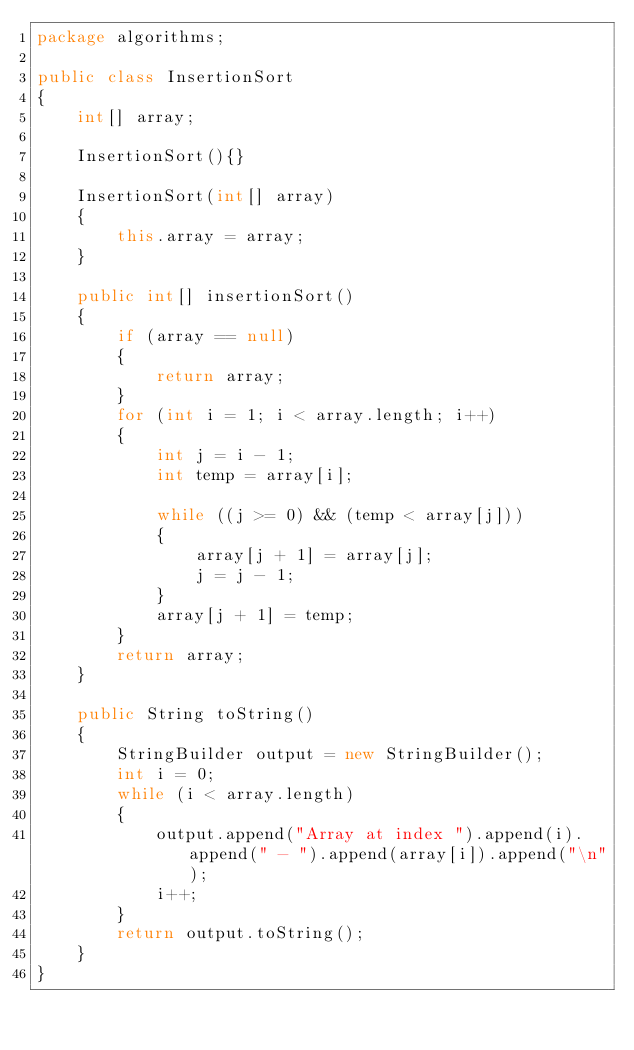Convert code to text. <code><loc_0><loc_0><loc_500><loc_500><_Java_>package algorithms;

public class InsertionSort
{
    int[] array;

    InsertionSort(){}

    InsertionSort(int[] array)
    {
        this.array = array;
    }

    public int[] insertionSort()
    {
        if (array == null)
        {
            return array;
        }
        for (int i = 1; i < array.length; i++)
        {
            int j = i - 1;
            int temp = array[i];

            while ((j >= 0) && (temp < array[j]))
            {
                array[j + 1] = array[j];
                j = j - 1;
            }
            array[j + 1] = temp;
        }
        return array;
    }

    public String toString()
    {
        StringBuilder output = new StringBuilder();
        int i = 0;
        while (i < array.length)
        {
            output.append("Array at index ").append(i).append(" - ").append(array[i]).append("\n");
            i++;
        }
        return output.toString();
    }
}
</code> 